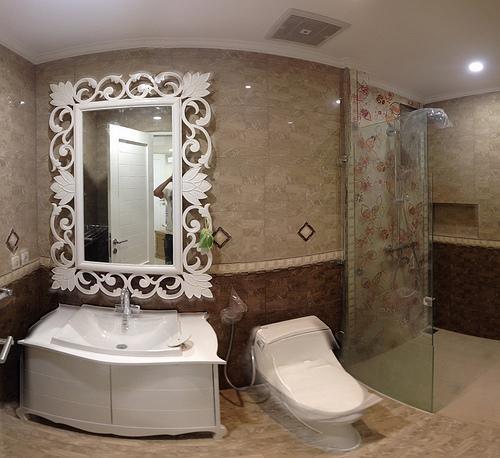How many mirrors are there?
Give a very brief answer. 1. 